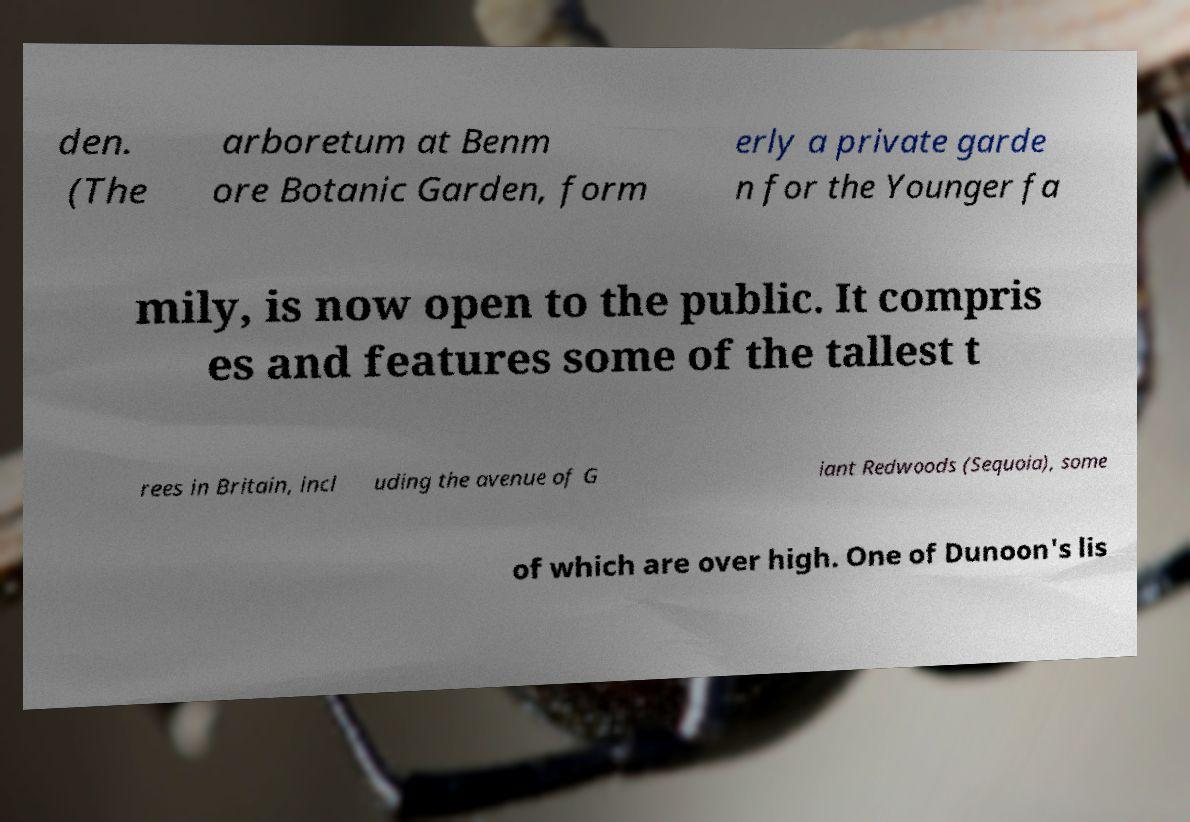For documentation purposes, I need the text within this image transcribed. Could you provide that? den. (The arboretum at Benm ore Botanic Garden, form erly a private garde n for the Younger fa mily, is now open to the public. It compris es and features some of the tallest t rees in Britain, incl uding the avenue of G iant Redwoods (Sequoia), some of which are over high. One of Dunoon's lis 